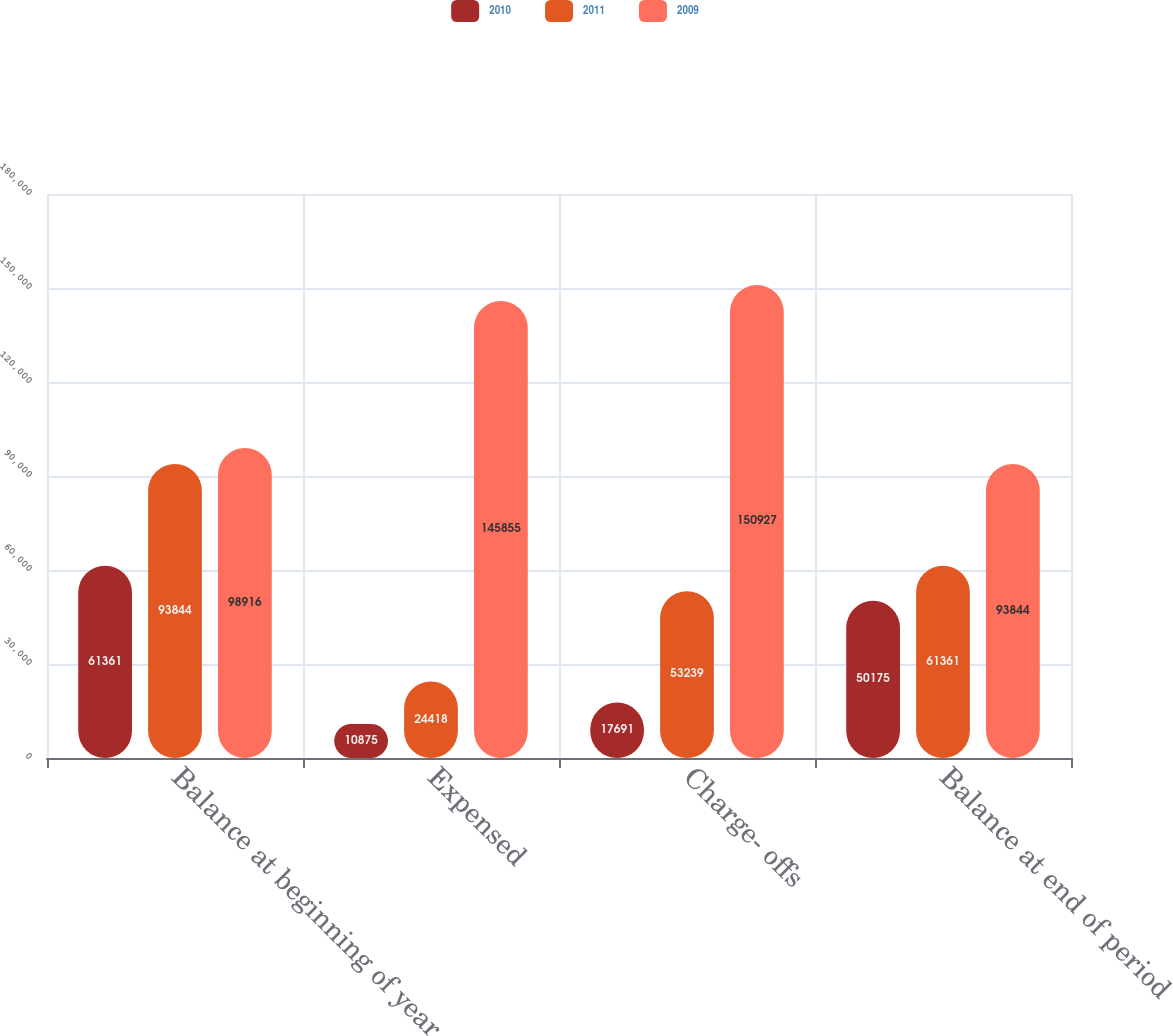Convert chart. <chart><loc_0><loc_0><loc_500><loc_500><stacked_bar_chart><ecel><fcel>Balance at beginning of year<fcel>Expensed<fcel>Charge- offs<fcel>Balance at end of period<nl><fcel>2010<fcel>61361<fcel>10875<fcel>17691<fcel>50175<nl><fcel>2011<fcel>93844<fcel>24418<fcel>53239<fcel>61361<nl><fcel>2009<fcel>98916<fcel>145855<fcel>150927<fcel>93844<nl></chart> 